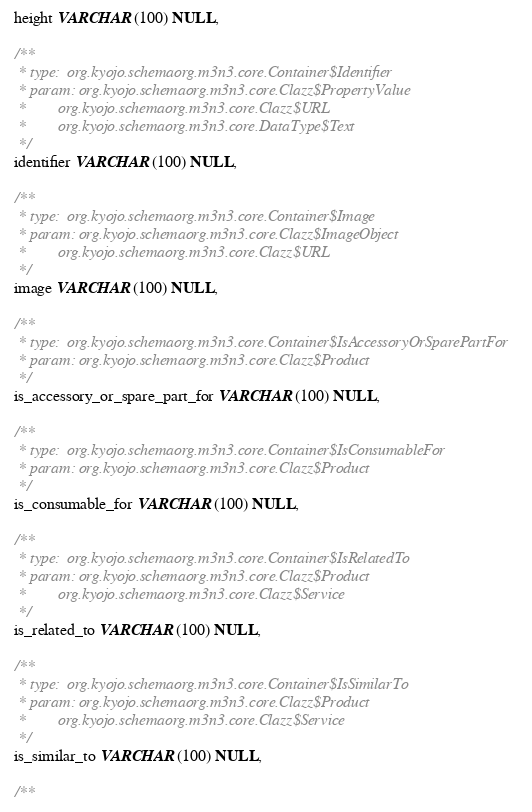Convert code to text. <code><loc_0><loc_0><loc_500><loc_500><_SQL_> height VARCHAR(100) NULL,

 /**
  * type:  org.kyojo.schemaorg.m3n3.core.Container$Identifier
  * param: org.kyojo.schemaorg.m3n3.core.Clazz$PropertyValue
  *        org.kyojo.schemaorg.m3n3.core.Clazz$URL
  *        org.kyojo.schemaorg.m3n3.core.DataType$Text
  */
 identifier VARCHAR(100) NULL,

 /**
  * type:  org.kyojo.schemaorg.m3n3.core.Container$Image
  * param: org.kyojo.schemaorg.m3n3.core.Clazz$ImageObject
  *        org.kyojo.schemaorg.m3n3.core.Clazz$URL
  */
 image VARCHAR(100) NULL,

 /**
  * type:  org.kyojo.schemaorg.m3n3.core.Container$IsAccessoryOrSparePartFor
  * param: org.kyojo.schemaorg.m3n3.core.Clazz$Product
  */
 is_accessory_or_spare_part_for VARCHAR(100) NULL,

 /**
  * type:  org.kyojo.schemaorg.m3n3.core.Container$IsConsumableFor
  * param: org.kyojo.schemaorg.m3n3.core.Clazz$Product
  */
 is_consumable_for VARCHAR(100) NULL,

 /**
  * type:  org.kyojo.schemaorg.m3n3.core.Container$IsRelatedTo
  * param: org.kyojo.schemaorg.m3n3.core.Clazz$Product
  *        org.kyojo.schemaorg.m3n3.core.Clazz$Service
  */
 is_related_to VARCHAR(100) NULL,

 /**
  * type:  org.kyojo.schemaorg.m3n3.core.Container$IsSimilarTo
  * param: org.kyojo.schemaorg.m3n3.core.Clazz$Product
  *        org.kyojo.schemaorg.m3n3.core.Clazz$Service
  */
 is_similar_to VARCHAR(100) NULL,

 /**</code> 